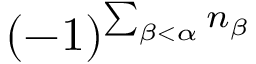<formula> <loc_0><loc_0><loc_500><loc_500>( - 1 ) ^ { \sum _ { \beta < \alpha } n _ { \beta } }</formula> 